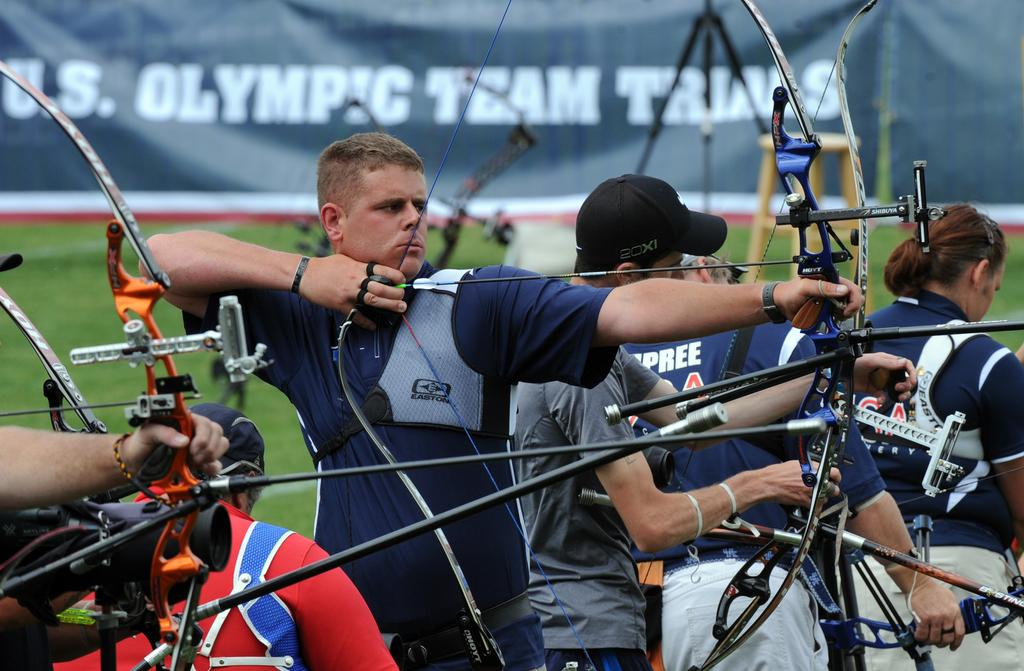What are the persons in the image holding? The persons in the image are holding bows and arrows. What activity is one person engaged in? There is a person sanding in the image. What can be seen in the background of the image? There is a banner and grass in the background of the image. Are there any objects related to photography in the image? Yes, there is a tripod stand in the background of the image. Can you hear the bells ringing in the image? There are no bells present in the image, so it is not possible to hear them ringing. What type of property is being sold in the image? There is no indication of any property being sold in the image. 